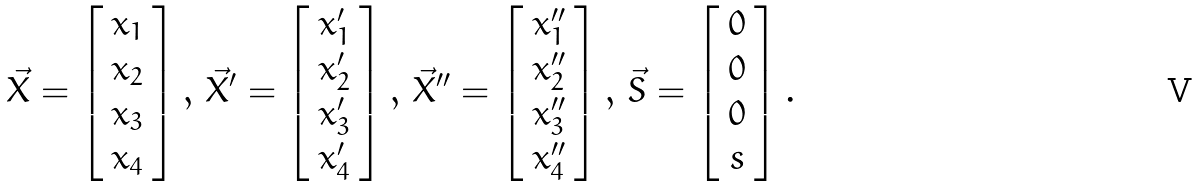Convert formula to latex. <formula><loc_0><loc_0><loc_500><loc_500>\vec { X } = \left [ \begin{array} { c } x _ { 1 } \\ x _ { 2 } \\ x _ { 3 } \\ x _ { 4 } \end{array} \right ] , \, \vec { X } ^ { \prime } = \left [ \begin{array} { c } x _ { 1 } ^ { \prime } \\ x _ { 2 } ^ { \prime } \\ x _ { 3 } ^ { \prime } \\ x _ { 4 } ^ { \prime } \end{array} \right ] , \, \vec { X } ^ { \prime \prime } = \left [ \begin{array} { c } x _ { 1 } ^ { \prime \prime } \\ x _ { 2 } ^ { \prime \prime } \\ x _ { 3 } ^ { \prime \prime } \\ x _ { 4 } ^ { \prime \prime } \end{array} \right ] , \, \vec { S } = \left [ \begin{array} { c } 0 \\ 0 \\ 0 \\ s \end{array} \right ] .</formula> 